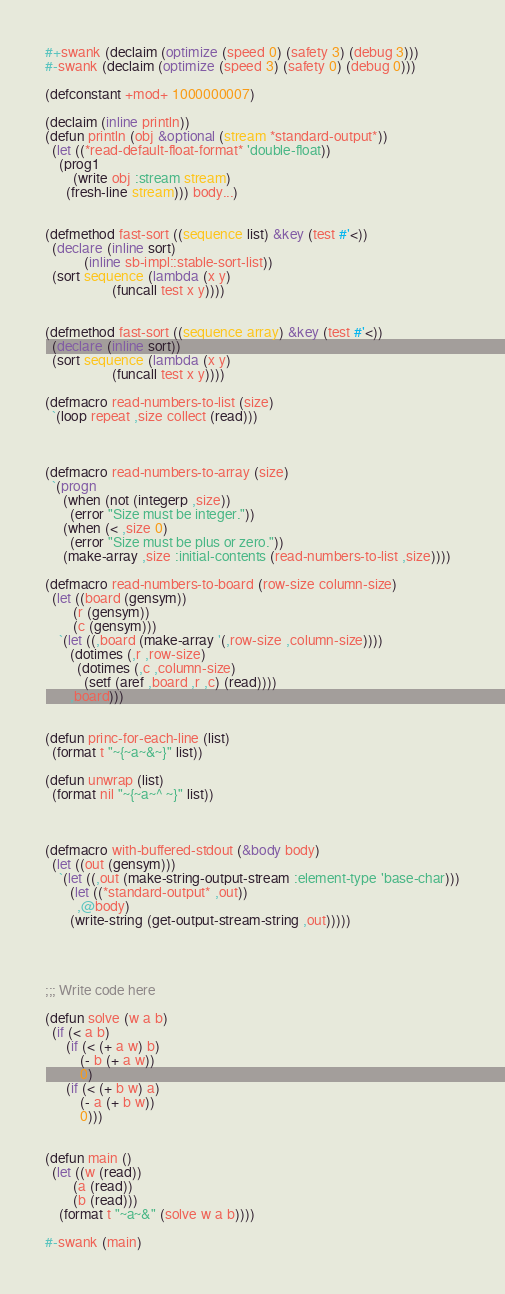Convert code to text. <code><loc_0><loc_0><loc_500><loc_500><_Lisp_>#+swank (declaim (optimize (speed 0) (safety 3) (debug 3)))
#-swank (declaim (optimize (speed 3) (safety 0) (debug 0)))

(defconstant +mod+ 1000000007)

(declaim (inline println))
(defun println (obj &optional (stream *standard-output*))
  (let ((*read-default-float-format* 'double-float))
    (prog1
        (write obj :stream stream)
      (fresh-line stream))) body...)


(defmethod fast-sort ((sequence list) &key (test #'<))
  (declare (inline sort)
           (inline sb-impl::stable-sort-list))
  (sort sequence (lambda (x y)
                   (funcall test x y))))


(defmethod fast-sort ((sequence array) &key (test #'<))
  (declare (inline sort))
  (sort sequence (lambda (x y)
                   (funcall test x y))))

(defmacro read-numbers-to-list (size)
  `(loop repeat ,size collect (read)))



(defmacro read-numbers-to-array (size)
  `(progn
     (when (not (integerp ,size))
       (error "Size must be integer."))
     (when (< ,size 0)
       (error "Size must be plus or zero."))
     (make-array ,size :initial-contents (read-numbers-to-list ,size))))

(defmacro read-numbers-to-board (row-size column-size)
  (let ((board (gensym))
        (r (gensym))
        (c (gensym)))
    `(let ((,board (make-array '(,row-size ,column-size))))
       (dotimes (,r ,row-size)
         (dotimes (,c ,column-size)
           (setf (aref ,board ,r ,c) (read))))
       ,board)))


(defun princ-for-each-line (list)
  (format t "~{~a~&~}" list))

(defun unwrap (list)
  (format nil "~{~a~^ ~}" list))



(defmacro with-buffered-stdout (&body body)
  (let ((out (gensym)))
    `(let ((,out (make-string-output-stream :element-type 'base-char)))
       (let ((*standard-output* ,out))
         ,@body)
       (write-string (get-output-stream-string ,out)))))




;;; Write code here

(defun solve (w a b)
  (if (< a b)
      (if (< (+ a w) b)
          (- b (+ a w))
          0)
      (if (< (+ b w) a)
          (- a (+ b w))
          0)))


(defun main ()
  (let ((w (read))
        (a (read))
        (b (read)))
    (format t "~a~&" (solve w a b))))

#-swank (main)
</code> 